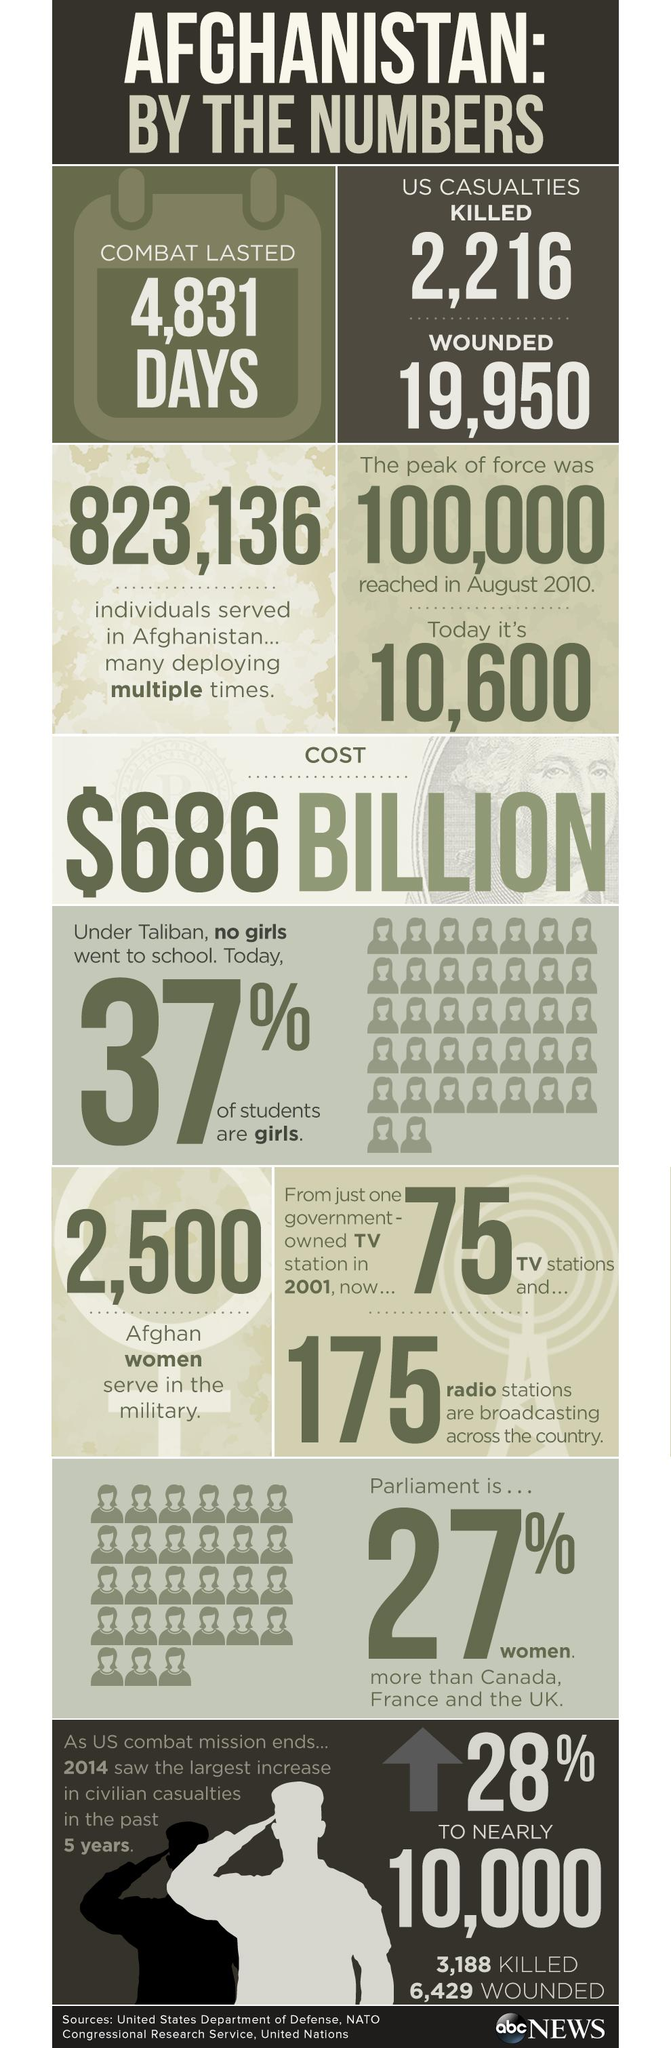Draw attention to some important aspects in this diagram. There are approximately 2,500 Afghan women currently serving in the military. The US combat mission in Afghanistan lasted for a total of 4,831 days. During the US combat mission in Afghanistan, 2,216 Americans were killed. 